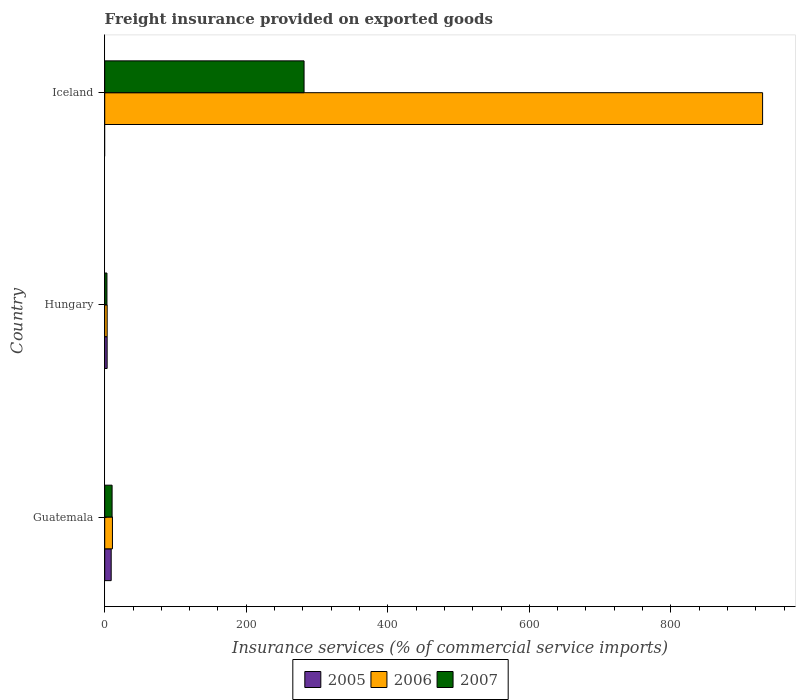How many different coloured bars are there?
Your answer should be compact. 3. How many groups of bars are there?
Provide a succinct answer. 3. Are the number of bars on each tick of the Y-axis equal?
Offer a terse response. No. What is the label of the 3rd group of bars from the top?
Your response must be concise. Guatemala. In how many cases, is the number of bars for a given country not equal to the number of legend labels?
Offer a terse response. 1. What is the freight insurance provided on exported goods in 2007 in Iceland?
Provide a succinct answer. 281.68. Across all countries, what is the maximum freight insurance provided on exported goods in 2007?
Ensure brevity in your answer.  281.68. Across all countries, what is the minimum freight insurance provided on exported goods in 2006?
Ensure brevity in your answer.  3.46. In which country was the freight insurance provided on exported goods in 2007 maximum?
Your answer should be very brief. Iceland. What is the total freight insurance provided on exported goods in 2005 in the graph?
Make the answer very short. 12.55. What is the difference between the freight insurance provided on exported goods in 2006 in Guatemala and that in Hungary?
Provide a short and direct response. 7.46. What is the difference between the freight insurance provided on exported goods in 2006 in Iceland and the freight insurance provided on exported goods in 2005 in Hungary?
Your response must be concise. 926.18. What is the average freight insurance provided on exported goods in 2005 per country?
Ensure brevity in your answer.  4.18. What is the difference between the freight insurance provided on exported goods in 2005 and freight insurance provided on exported goods in 2007 in Guatemala?
Give a very brief answer. -1.27. What is the ratio of the freight insurance provided on exported goods in 2005 in Guatemala to that in Hungary?
Your answer should be very brief. 2.68. Is the difference between the freight insurance provided on exported goods in 2005 in Guatemala and Hungary greater than the difference between the freight insurance provided on exported goods in 2007 in Guatemala and Hungary?
Your answer should be compact. No. What is the difference between the highest and the second highest freight insurance provided on exported goods in 2006?
Provide a succinct answer. 918.68. What is the difference between the highest and the lowest freight insurance provided on exported goods in 2006?
Provide a succinct answer. 926.14. Is it the case that in every country, the sum of the freight insurance provided on exported goods in 2006 and freight insurance provided on exported goods in 2007 is greater than the freight insurance provided on exported goods in 2005?
Ensure brevity in your answer.  Yes. How many countries are there in the graph?
Offer a terse response. 3. Does the graph contain any zero values?
Provide a succinct answer. Yes. Does the graph contain grids?
Offer a very short reply. No. Where does the legend appear in the graph?
Provide a short and direct response. Bottom center. How many legend labels are there?
Your response must be concise. 3. How are the legend labels stacked?
Offer a terse response. Horizontal. What is the title of the graph?
Provide a short and direct response. Freight insurance provided on exported goods. Does "2012" appear as one of the legend labels in the graph?
Your answer should be compact. No. What is the label or title of the X-axis?
Give a very brief answer. Insurance services (% of commercial service imports). What is the label or title of the Y-axis?
Provide a succinct answer. Country. What is the Insurance services (% of commercial service imports) in 2005 in Guatemala?
Provide a succinct answer. 9.14. What is the Insurance services (% of commercial service imports) of 2006 in Guatemala?
Provide a short and direct response. 10.92. What is the Insurance services (% of commercial service imports) of 2007 in Guatemala?
Provide a short and direct response. 10.41. What is the Insurance services (% of commercial service imports) in 2005 in Hungary?
Make the answer very short. 3.41. What is the Insurance services (% of commercial service imports) of 2006 in Hungary?
Your answer should be very brief. 3.46. What is the Insurance services (% of commercial service imports) of 2007 in Hungary?
Ensure brevity in your answer.  3.16. What is the Insurance services (% of commercial service imports) in 2005 in Iceland?
Keep it short and to the point. 0. What is the Insurance services (% of commercial service imports) of 2006 in Iceland?
Your response must be concise. 929.6. What is the Insurance services (% of commercial service imports) of 2007 in Iceland?
Offer a very short reply. 281.68. Across all countries, what is the maximum Insurance services (% of commercial service imports) in 2005?
Offer a very short reply. 9.14. Across all countries, what is the maximum Insurance services (% of commercial service imports) of 2006?
Give a very brief answer. 929.6. Across all countries, what is the maximum Insurance services (% of commercial service imports) of 2007?
Provide a succinct answer. 281.68. Across all countries, what is the minimum Insurance services (% of commercial service imports) of 2006?
Ensure brevity in your answer.  3.46. Across all countries, what is the minimum Insurance services (% of commercial service imports) in 2007?
Your response must be concise. 3.16. What is the total Insurance services (% of commercial service imports) in 2005 in the graph?
Your answer should be compact. 12.55. What is the total Insurance services (% of commercial service imports) of 2006 in the graph?
Ensure brevity in your answer.  943.98. What is the total Insurance services (% of commercial service imports) of 2007 in the graph?
Make the answer very short. 295.25. What is the difference between the Insurance services (% of commercial service imports) in 2005 in Guatemala and that in Hungary?
Your answer should be very brief. 5.73. What is the difference between the Insurance services (% of commercial service imports) of 2006 in Guatemala and that in Hungary?
Provide a short and direct response. 7.46. What is the difference between the Insurance services (% of commercial service imports) in 2007 in Guatemala and that in Hungary?
Your answer should be very brief. 7.25. What is the difference between the Insurance services (% of commercial service imports) in 2006 in Guatemala and that in Iceland?
Your answer should be very brief. -918.68. What is the difference between the Insurance services (% of commercial service imports) in 2007 in Guatemala and that in Iceland?
Give a very brief answer. -271.27. What is the difference between the Insurance services (% of commercial service imports) in 2006 in Hungary and that in Iceland?
Provide a succinct answer. -926.14. What is the difference between the Insurance services (% of commercial service imports) in 2007 in Hungary and that in Iceland?
Ensure brevity in your answer.  -278.52. What is the difference between the Insurance services (% of commercial service imports) in 2005 in Guatemala and the Insurance services (% of commercial service imports) in 2006 in Hungary?
Make the answer very short. 5.68. What is the difference between the Insurance services (% of commercial service imports) of 2005 in Guatemala and the Insurance services (% of commercial service imports) of 2007 in Hungary?
Provide a short and direct response. 5.98. What is the difference between the Insurance services (% of commercial service imports) in 2006 in Guatemala and the Insurance services (% of commercial service imports) in 2007 in Hungary?
Ensure brevity in your answer.  7.76. What is the difference between the Insurance services (% of commercial service imports) of 2005 in Guatemala and the Insurance services (% of commercial service imports) of 2006 in Iceland?
Make the answer very short. -920.46. What is the difference between the Insurance services (% of commercial service imports) in 2005 in Guatemala and the Insurance services (% of commercial service imports) in 2007 in Iceland?
Offer a terse response. -272.54. What is the difference between the Insurance services (% of commercial service imports) of 2006 in Guatemala and the Insurance services (% of commercial service imports) of 2007 in Iceland?
Make the answer very short. -270.76. What is the difference between the Insurance services (% of commercial service imports) of 2005 in Hungary and the Insurance services (% of commercial service imports) of 2006 in Iceland?
Offer a very short reply. -926.18. What is the difference between the Insurance services (% of commercial service imports) of 2005 in Hungary and the Insurance services (% of commercial service imports) of 2007 in Iceland?
Your answer should be very brief. -278.26. What is the difference between the Insurance services (% of commercial service imports) in 2006 in Hungary and the Insurance services (% of commercial service imports) in 2007 in Iceland?
Your response must be concise. -278.22. What is the average Insurance services (% of commercial service imports) in 2005 per country?
Make the answer very short. 4.18. What is the average Insurance services (% of commercial service imports) of 2006 per country?
Your response must be concise. 314.66. What is the average Insurance services (% of commercial service imports) of 2007 per country?
Make the answer very short. 98.42. What is the difference between the Insurance services (% of commercial service imports) in 2005 and Insurance services (% of commercial service imports) in 2006 in Guatemala?
Your response must be concise. -1.78. What is the difference between the Insurance services (% of commercial service imports) of 2005 and Insurance services (% of commercial service imports) of 2007 in Guatemala?
Provide a succinct answer. -1.27. What is the difference between the Insurance services (% of commercial service imports) of 2006 and Insurance services (% of commercial service imports) of 2007 in Guatemala?
Keep it short and to the point. 0.51. What is the difference between the Insurance services (% of commercial service imports) of 2005 and Insurance services (% of commercial service imports) of 2006 in Hungary?
Provide a short and direct response. -0.05. What is the difference between the Insurance services (% of commercial service imports) in 2005 and Insurance services (% of commercial service imports) in 2007 in Hungary?
Make the answer very short. 0.26. What is the difference between the Insurance services (% of commercial service imports) in 2006 and Insurance services (% of commercial service imports) in 2007 in Hungary?
Your response must be concise. 0.3. What is the difference between the Insurance services (% of commercial service imports) in 2006 and Insurance services (% of commercial service imports) in 2007 in Iceland?
Keep it short and to the point. 647.92. What is the ratio of the Insurance services (% of commercial service imports) of 2005 in Guatemala to that in Hungary?
Offer a very short reply. 2.68. What is the ratio of the Insurance services (% of commercial service imports) in 2006 in Guatemala to that in Hungary?
Make the answer very short. 3.16. What is the ratio of the Insurance services (% of commercial service imports) of 2007 in Guatemala to that in Hungary?
Keep it short and to the point. 3.3. What is the ratio of the Insurance services (% of commercial service imports) in 2006 in Guatemala to that in Iceland?
Offer a terse response. 0.01. What is the ratio of the Insurance services (% of commercial service imports) in 2007 in Guatemala to that in Iceland?
Your answer should be very brief. 0.04. What is the ratio of the Insurance services (% of commercial service imports) in 2006 in Hungary to that in Iceland?
Ensure brevity in your answer.  0. What is the ratio of the Insurance services (% of commercial service imports) of 2007 in Hungary to that in Iceland?
Give a very brief answer. 0.01. What is the difference between the highest and the second highest Insurance services (% of commercial service imports) in 2006?
Keep it short and to the point. 918.68. What is the difference between the highest and the second highest Insurance services (% of commercial service imports) in 2007?
Your response must be concise. 271.27. What is the difference between the highest and the lowest Insurance services (% of commercial service imports) in 2005?
Offer a terse response. 9.14. What is the difference between the highest and the lowest Insurance services (% of commercial service imports) in 2006?
Offer a terse response. 926.14. What is the difference between the highest and the lowest Insurance services (% of commercial service imports) in 2007?
Make the answer very short. 278.52. 